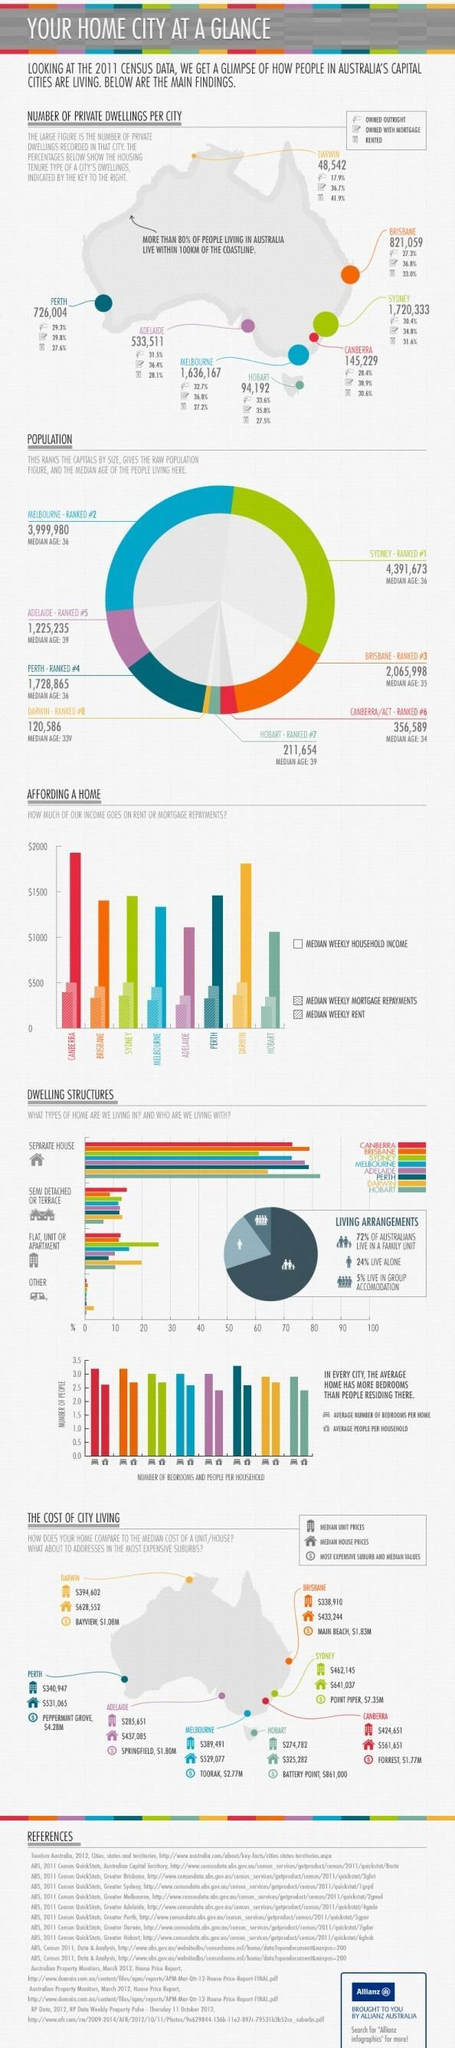What percentage of Australians not live in a family unit?
Answer the question with a short phrase. 28% What percentage not live alone? 76% What percentage not live in group accommodation? 95% 